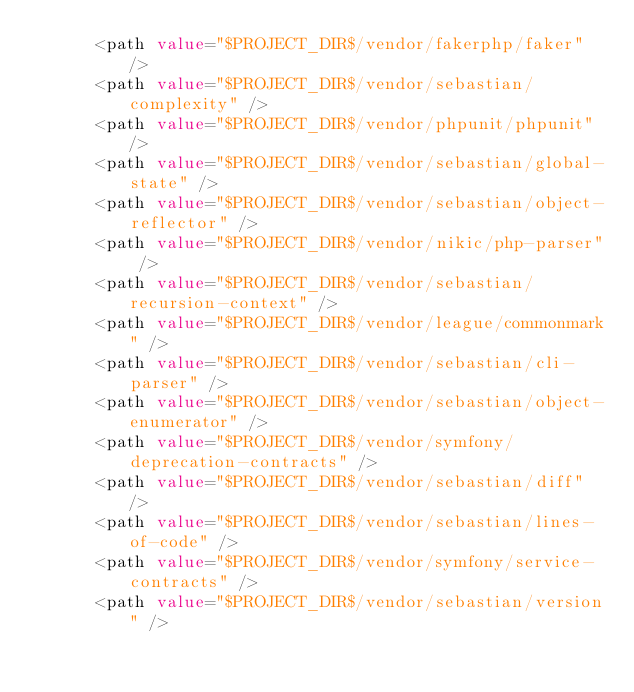Convert code to text. <code><loc_0><loc_0><loc_500><loc_500><_XML_>      <path value="$PROJECT_DIR$/vendor/fakerphp/faker" />
      <path value="$PROJECT_DIR$/vendor/sebastian/complexity" />
      <path value="$PROJECT_DIR$/vendor/phpunit/phpunit" />
      <path value="$PROJECT_DIR$/vendor/sebastian/global-state" />
      <path value="$PROJECT_DIR$/vendor/sebastian/object-reflector" />
      <path value="$PROJECT_DIR$/vendor/nikic/php-parser" />
      <path value="$PROJECT_DIR$/vendor/sebastian/recursion-context" />
      <path value="$PROJECT_DIR$/vendor/league/commonmark" />
      <path value="$PROJECT_DIR$/vendor/sebastian/cli-parser" />
      <path value="$PROJECT_DIR$/vendor/sebastian/object-enumerator" />
      <path value="$PROJECT_DIR$/vendor/symfony/deprecation-contracts" />
      <path value="$PROJECT_DIR$/vendor/sebastian/diff" />
      <path value="$PROJECT_DIR$/vendor/sebastian/lines-of-code" />
      <path value="$PROJECT_DIR$/vendor/symfony/service-contracts" />
      <path value="$PROJECT_DIR$/vendor/sebastian/version" /></code> 